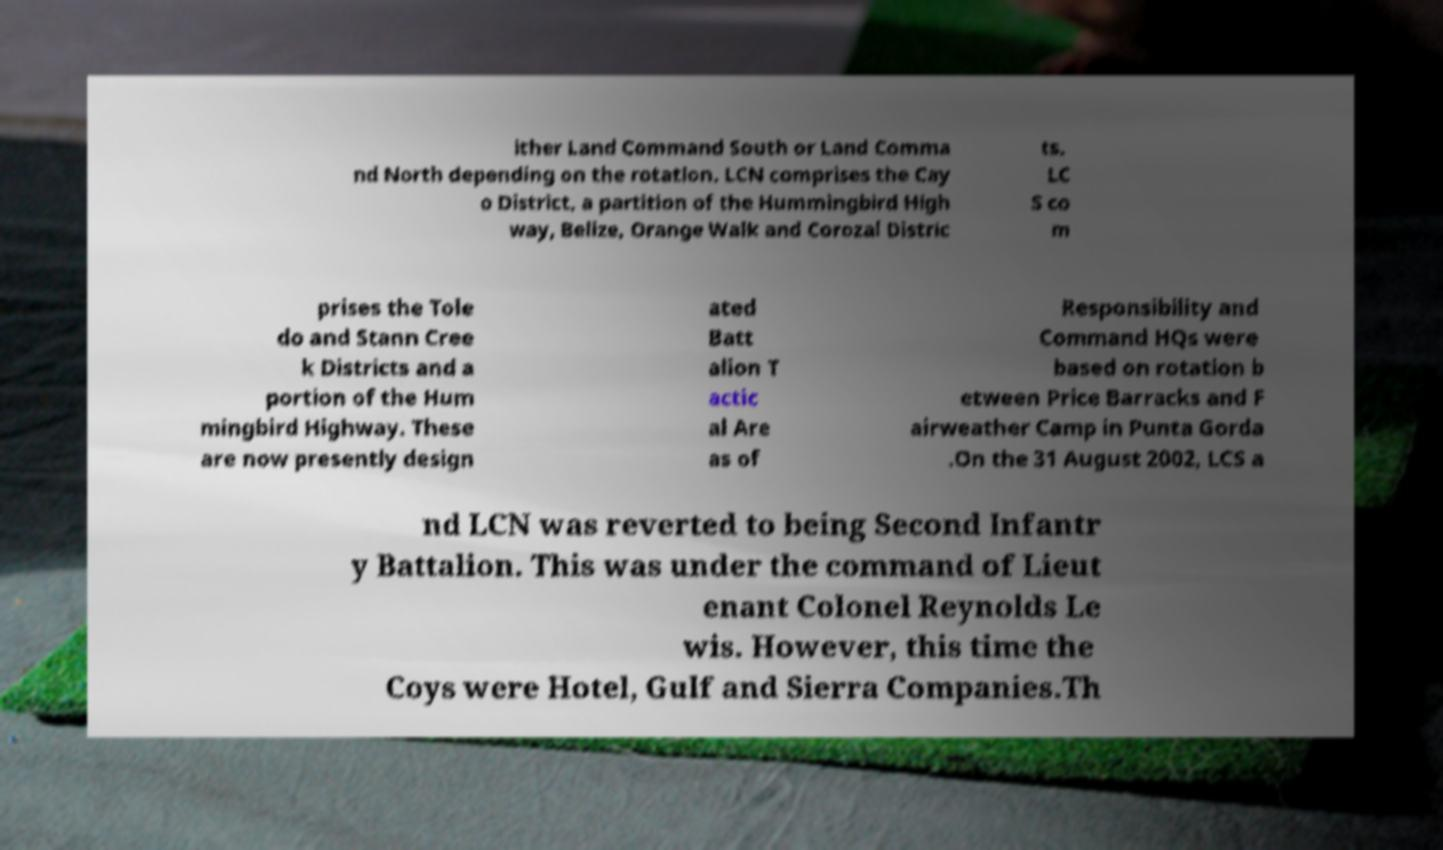Please read and relay the text visible in this image. What does it say? ither Land Command South or Land Comma nd North depending on the rotation. LCN comprises the Cay o District, a partition of the Hummingbird High way, Belize, Orange Walk and Corozal Distric ts. LC S co m prises the Tole do and Stann Cree k Districts and a portion of the Hum mingbird Highway. These are now presently design ated Batt alion T actic al Are as of Responsibility and Command HQs were based on rotation b etween Price Barracks and F airweather Camp in Punta Gorda .On the 31 August 2002, LCS a nd LCN was reverted to being Second Infantr y Battalion. This was under the command of Lieut enant Colonel Reynolds Le wis. However, this time the Coys were Hotel, Gulf and Sierra Companies.Th 